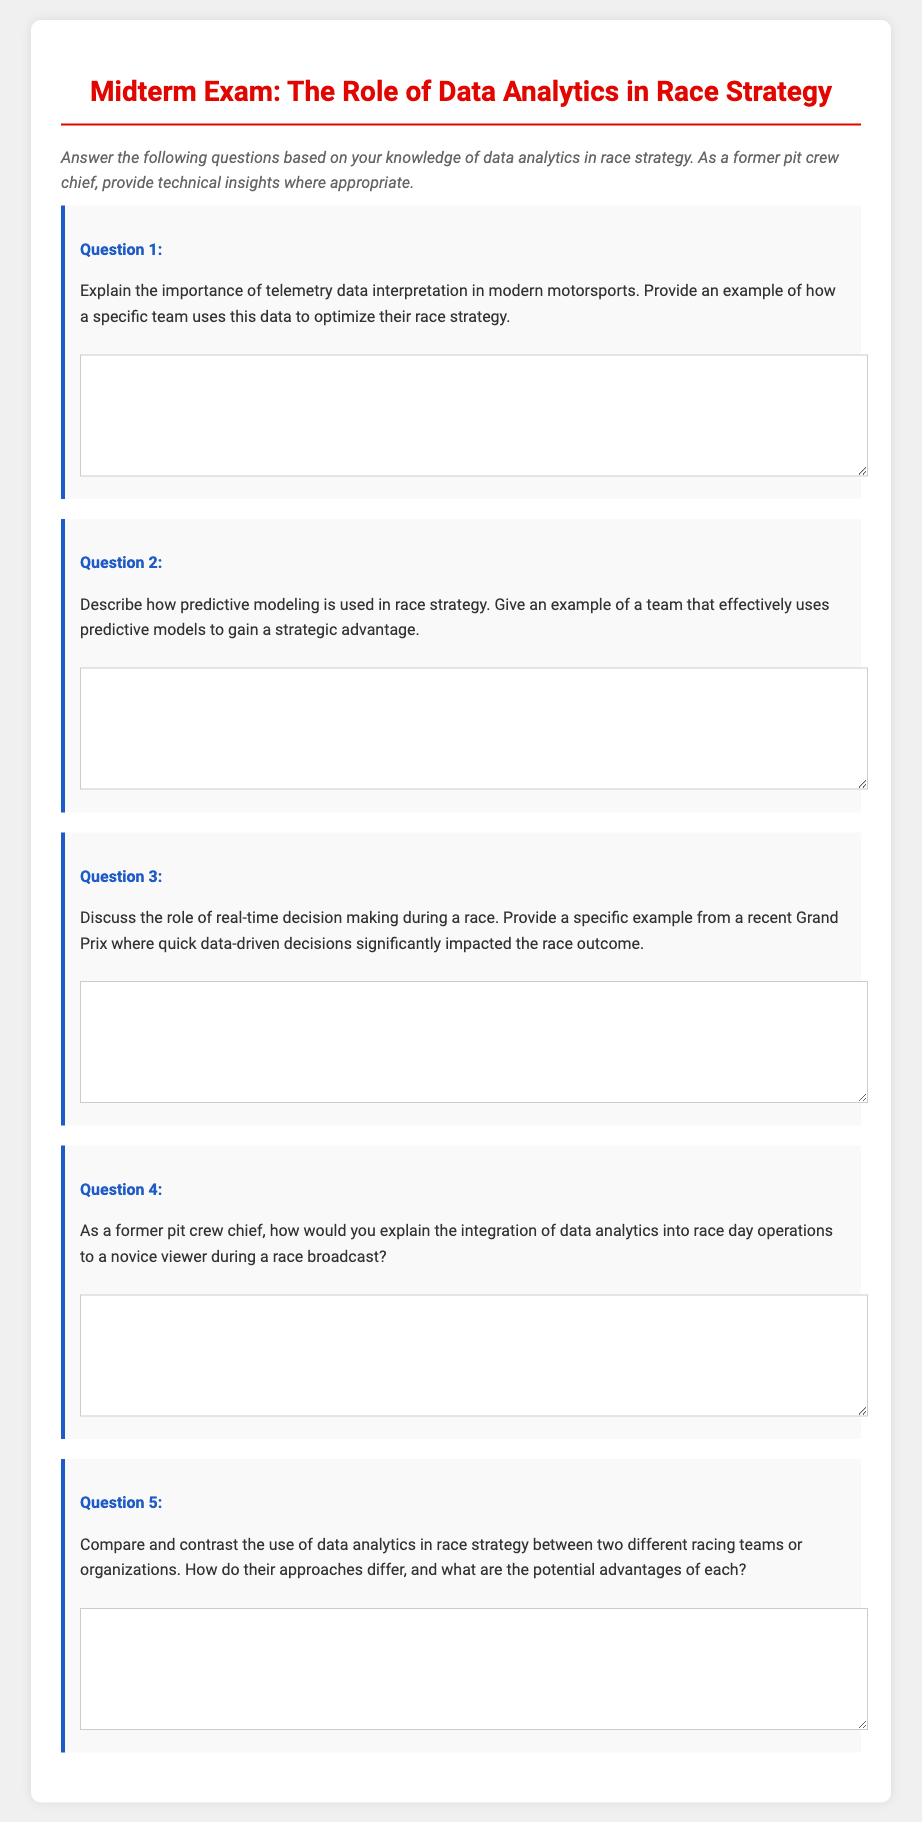What is the title of the document? The title of the document is found at the top of the rendered content, specifying the focus of the midterm exam.
Answer: Midterm Exam: The Role of Data Analytics in Race Strategy How many questions are included in the exam? The document lists a total of five distinct questions for students to answer.
Answer: 5 What is the color used for the question number? The document indicates that the question number is highlighted with a specific color style for emphasis.
Answer: #1e5bc6 What is the main instruction provided to the students? The instruction prompts students to utilize their knowledge of data analytics in race strategy to answer the exam questions.
Answer: Answer the following questions based on your knowledge of data analytics in race strategy Which role does telemetry data interpretation play in motorsports according to Question 1? The question hints at the significance of understanding telemetry data in formulating effective race strategies.
Answer: Importance in modern motorsports What type of question is Question 4 categorized as? The nature of the question indicates an explanation geared towards communicating complex concepts in an accessible manner.
Answer: Integration of data analytics into race day operations What is the background color of the exam document? The overall design choice for the document creates a specific aesthetic environment for the content presentation.
Answer: #f0f0f0 What is the main focus of Question 2? The question prompts a discussion on how predictive modeling is utilized in race strategy for competitive advantages.
Answer: Predictive modeling in race strategy What specific field is referenced in the instruction section? The instruction is particularly focused on a specialized area that combines sporting strategies and data analysis.
Answer: Race strategy 